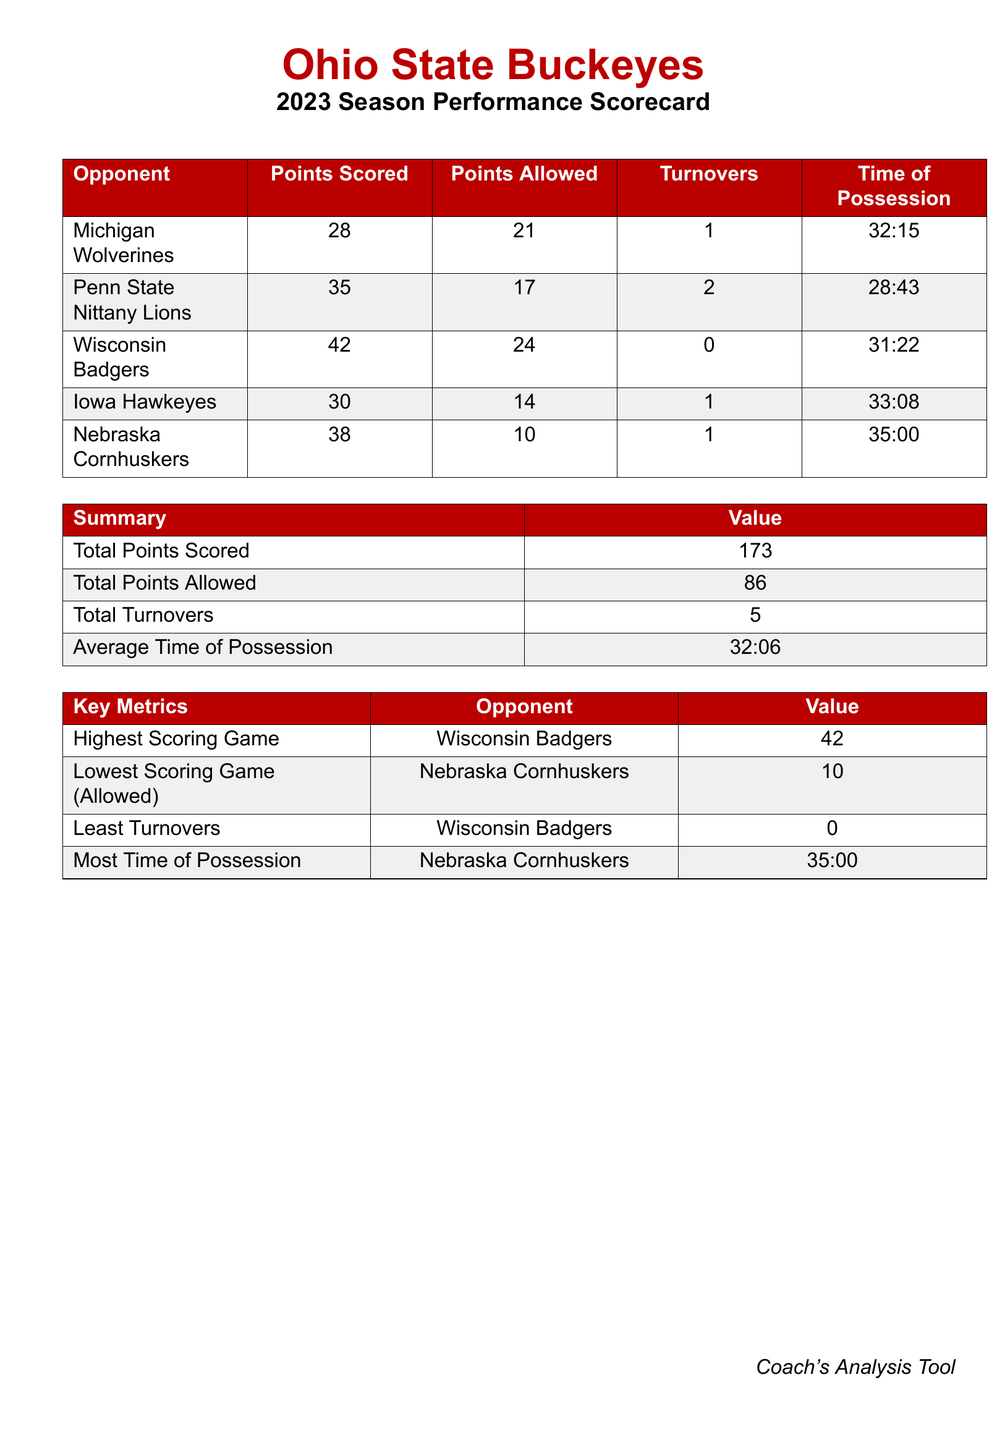What is the total points scored? The total points scored is calculated by adding the points scored in all games: 28 + 35 + 42 + 30 + 38 = 173.
Answer: 173 What is the lowest scoring game allowed? The lowest scoring game allowed is the game against the Nebraska Cornhuskers, where they scored 10 points.
Answer: 10 Who had the highest scoring game? The highest scoring game was against the Wisconsin Badgers, where the team scored 42 points.
Answer: Wisconsin Badgers What is the average time of possession? The average time of possession is the total time divided by the number of games, which is calculated as 32:06.
Answer: 32:06 How many total turnovers occurred? The total turnovers are the sum of turnovers across all games, which is 1 + 2 + 0 + 1 + 1 = 5.
Answer: 5 What was the most time of possession in a single game? The most time of possession occurred in the game against the Nebraska Cornhuskers, lasting 35:00.
Answer: 35:00 What are the points scored against the Iowa Hawkeyes? The points scored against the Iowa Hawkeyes is directly stated as 30 points.
Answer: 30 Which opponent allowed the least turnovers? The opponent that allowed the least turnovers in a game was the Wisconsin Badgers with 0 turnovers.
Answer: Wisconsin Badgers 